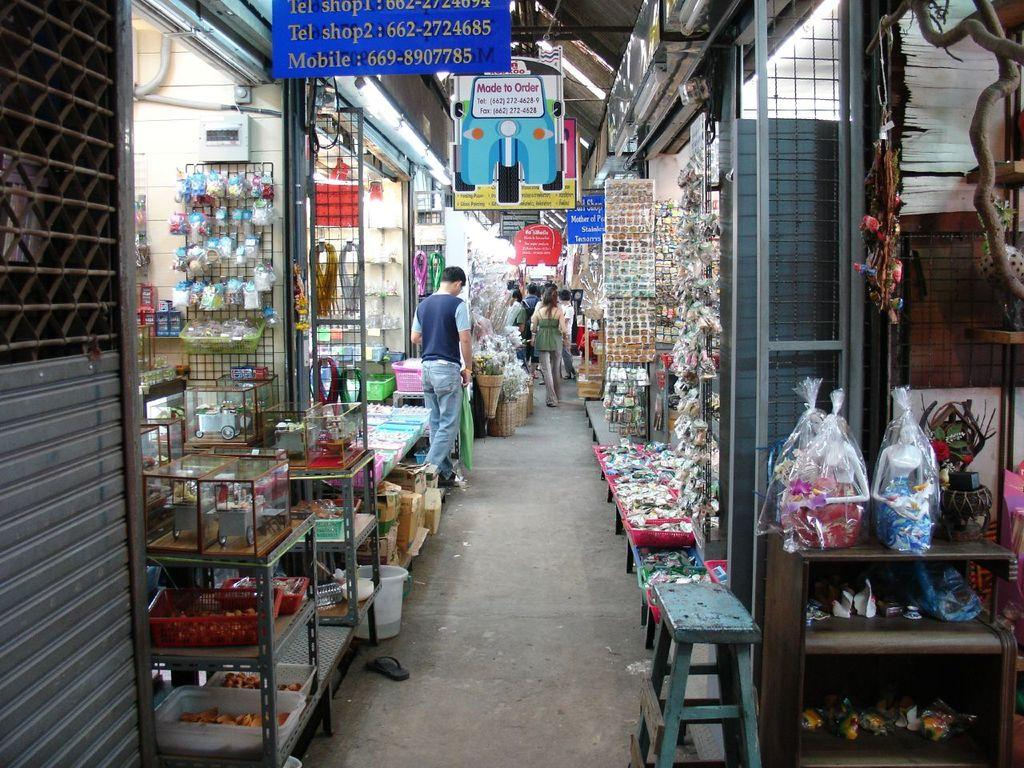Who or what can be seen in the image? There are people in the image. What can be found on the left and right sides of the image? There are objects on shelves on the left and right sides of the image. What is located at the top of the image? There is a board with text at the top of the image. What type of sound can be heard coming from the park in the image? There is no park present in the image, so it's not possible to determine what, if any, sounds might be heard. 